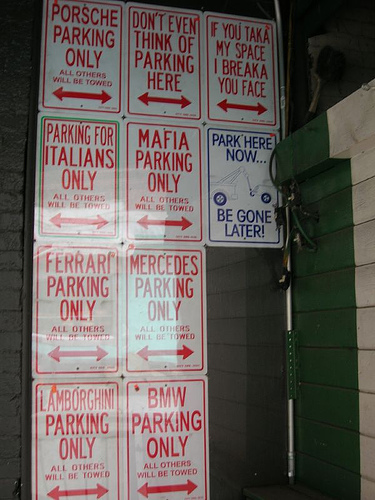<image>
Is the sign on the wall? Yes. Looking at the image, I can see the sign is positioned on top of the wall, with the wall providing support. 